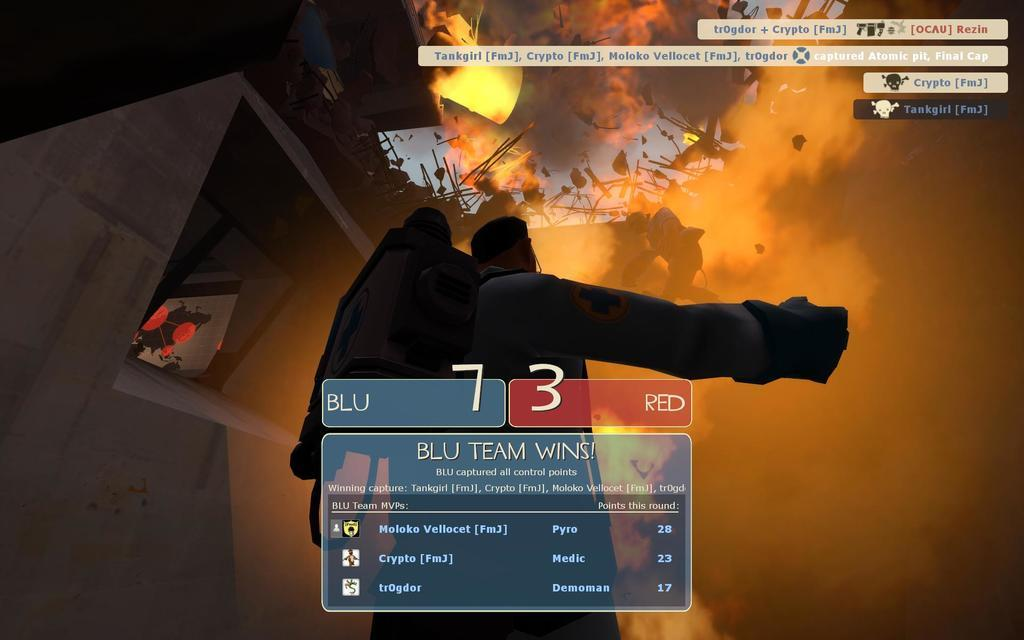<image>
Render a clear and concise summary of the photo. a scene from a game with the words blu and red halfway down 